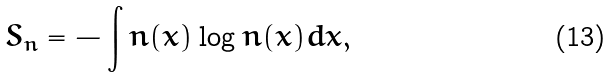<formula> <loc_0><loc_0><loc_500><loc_500>S _ { n } = - \int n ( x ) \log n ( x ) d x ,</formula> 